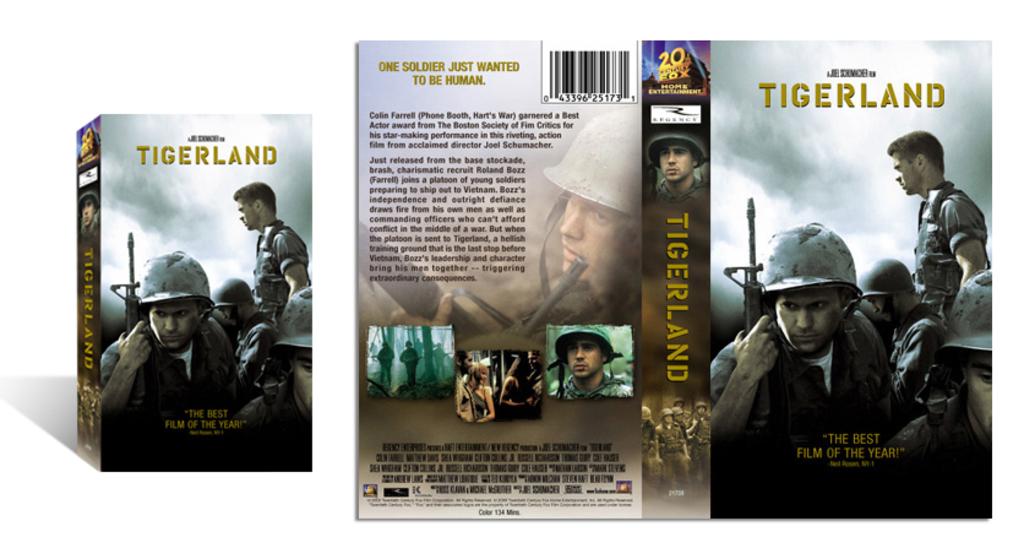What is the name of this movie?
Give a very brief answer. Tigerland. What is the tagline on the back of the box?
Give a very brief answer. One soldier just wanted to be human. 